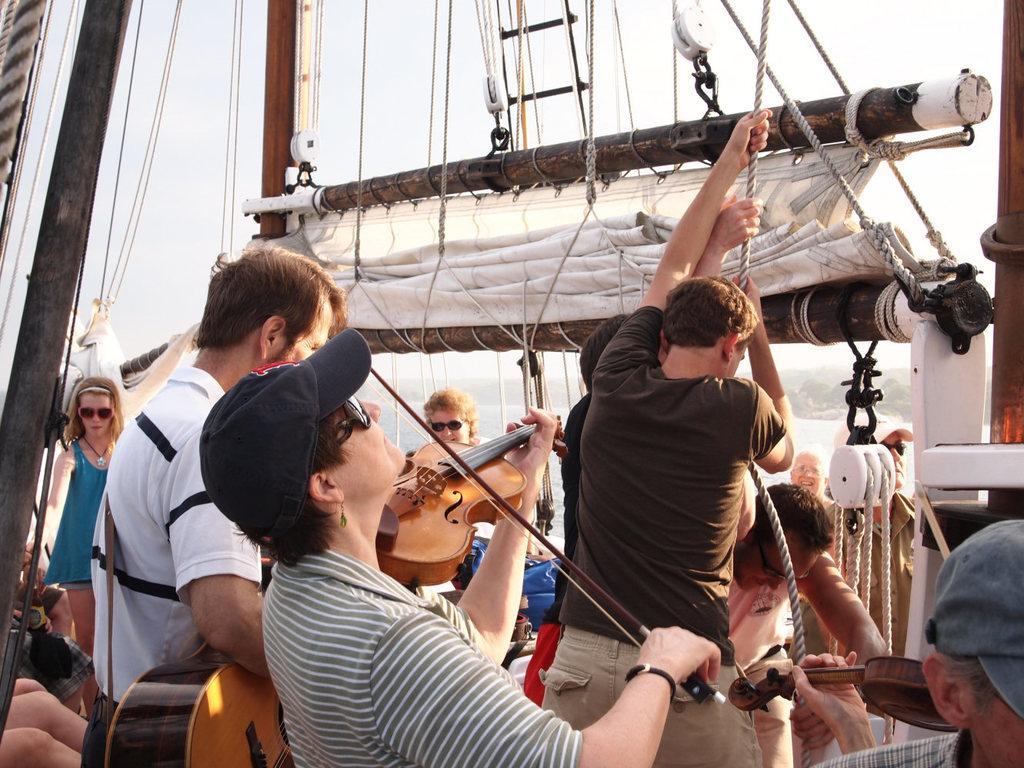Could you give a brief overview of what you see in this image? At the top we can see sky. Here we can see ropes and rods to which curtains are folded. Here we can see few persons standing and holding this rope. We can this person wearing a cap and goggles playing a violin. Aside to this person we can see a man holding a guitar. 